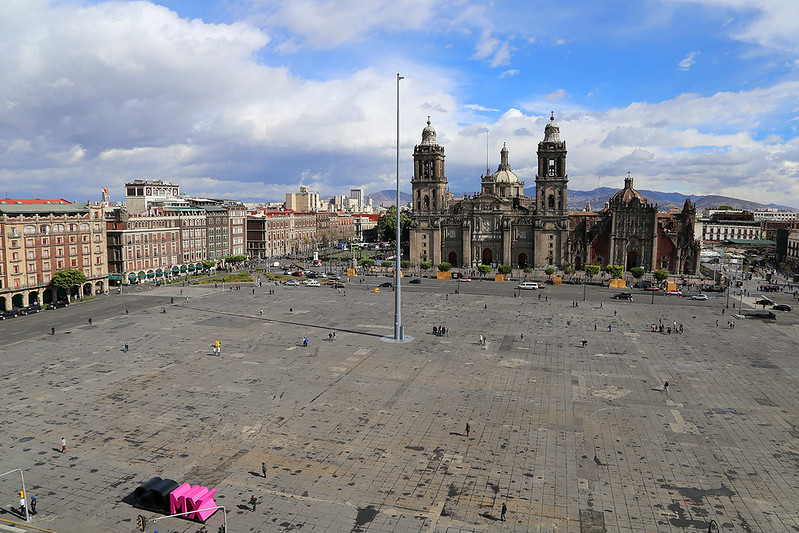Can you give me some historical context about the buildings surrounding the Zócalo? Certainly! The buildings surrounding the Zócalo in Mexico City are steeped in history. The most prominent structure is the Metropolitan Cathedral, located on the north side of the square. It was built between the 16th and 17th centuries, making it one of the oldest and largest cathedrals in the Americas. Its architecture reflects a blend of Gothic, Baroque, and Neoclassical styles.

Adjacent to the cathedral is the National Palace, the seat of the federal executive in Mexico. This building stands on the site of the original palace of Moctezuma II and has been expanded and altered over the centuries. It houses important murals by Diego Rivera that depict the history of Mexico from the pre-Columbian era to the Mexican Revolution.

The surrounding area also includes various other colonial-era buildings, such as the Old Portal de Mercaderes and the Supreme Court of Justice. Many of these structures were built over the ruins of Tenochtitlán, the ancient Aztec capital, blending pre-Hispanic and colonial histories in their foundations. 